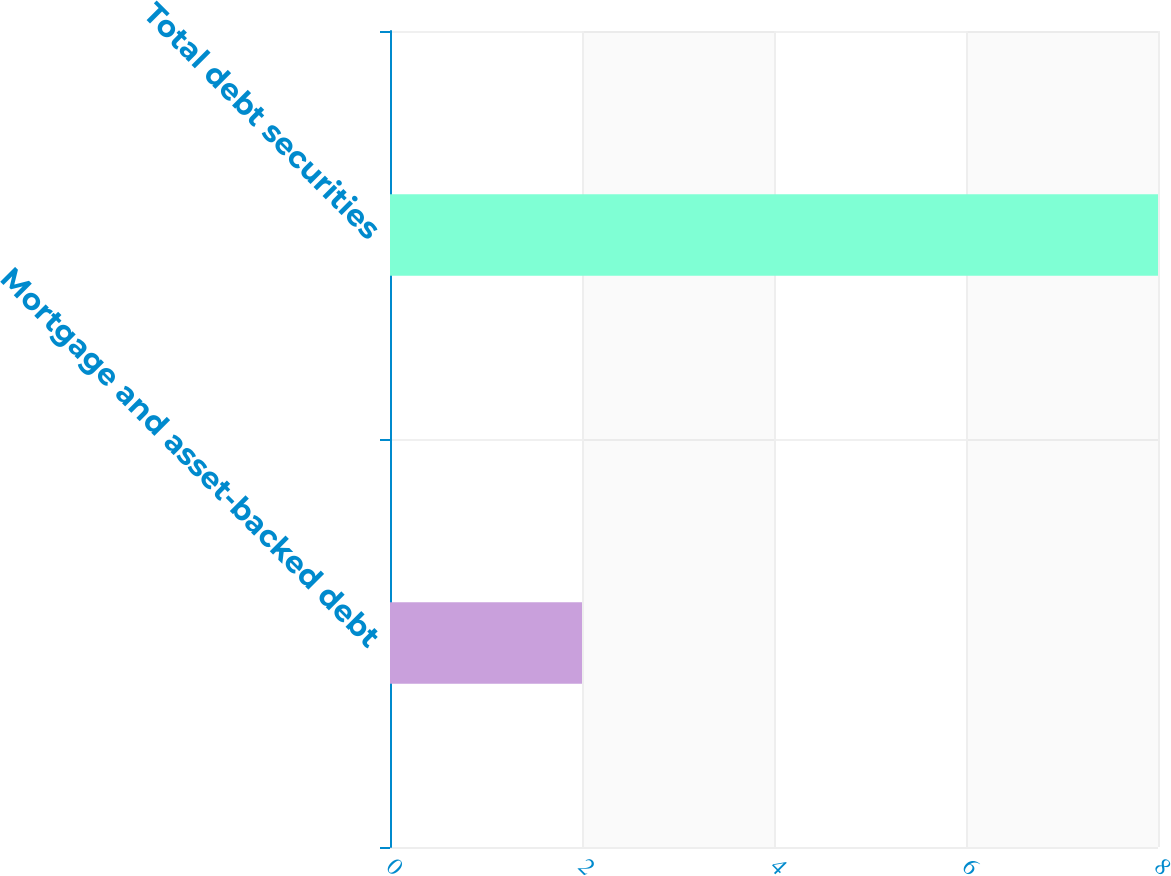<chart> <loc_0><loc_0><loc_500><loc_500><bar_chart><fcel>Mortgage and asset-backed debt<fcel>Total debt securities<nl><fcel>2<fcel>8<nl></chart> 